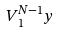<formula> <loc_0><loc_0><loc_500><loc_500>V _ { 1 } ^ { N - 1 } y</formula> 